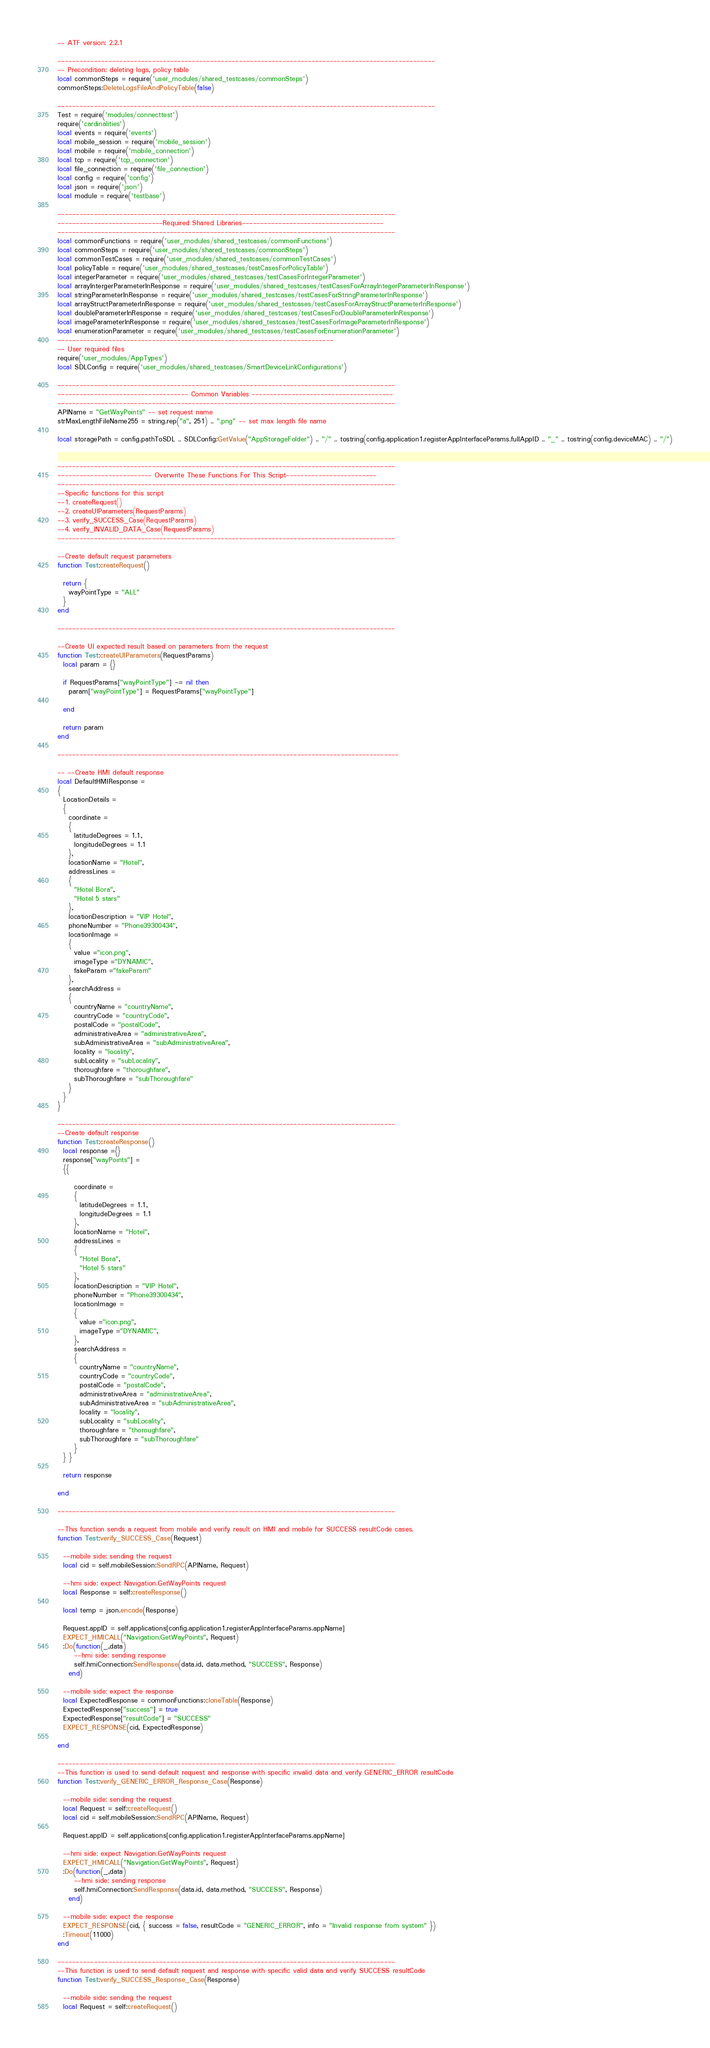<code> <loc_0><loc_0><loc_500><loc_500><_Lua_>-- ATF version: 2.2.1

--------------------------------------------------------------------------------------------------------
-- Precondition: deleting logs, policy table
local commonSteps = require('user_modules/shared_testcases/commonSteps')
commonSteps:DeleteLogsFileAndPolicyTable(false)

--------------------------------------------------------------------------------------------------------
Test = require('modules/connecttest')
require('cardinalities')
local events = require('events')
local mobile_session = require('mobile_session')
local mobile = require('mobile_connection')
local tcp = require('tcp_connection')
local file_connection = require('file_connection')
local config = require('config')
local json = require('json')
local module = require('testbase')

---------------------------------------------------------------------------------------------
-----------------------------Required Shared Libraries---------------------------------------
---------------------------------------------------------------------------------------------
local commonFunctions = require('user_modules/shared_testcases/commonFunctions')
local commonSteps = require('user_modules/shared_testcases/commonSteps')
local commonTestCases = require('user_modules/shared_testcases/commonTestCases')
local policyTable = require('user_modules/shared_testcases/testCasesForPolicyTable')
local integerParameter = require('user_modules/shared_testcases/testCasesForIntegerParameter')
local arrayIntergerParameterInResponse = require('user_modules/shared_testcases/testCasesForArrayIntegerParameterInResponse')
local stringParameterInResponse = require('user_modules/shared_testcases/testCasesForStringParameterInResponse')
local arrayStructParameterInResponse = require('user_modules/shared_testcases/testCasesForArrayStructParameterInResponse')
local doubleParameterInResponse = require('user_modules/shared_testcases/testCasesForDoubleParameterInResponse')
local imageParameterInResponse = require('user_modules/shared_testcases/testCasesForImageParameterInResponse')
local enumerationParameter = require('user_modules/shared_testcases/testCasesForEnumerationParameter')
----------------------------------------------------------------------------
-- User required files
require('user_modules/AppTypes')
local SDLConfig = require('user_modules/shared_testcases/SmartDeviceLinkConfigurations')

---------------------------------------------------------------------------------------------
------------------------------------ Common Variables ---------------------------------------
---------------------------------------------------------------------------------------------
APIName = "GetWayPoints" -- set request name
strMaxLengthFileName255 = string.rep("a", 251) .. ".png" -- set max length file name

local storagePath = config.pathToSDL .. SDLConfig:GetValue("AppStorageFolder") .. "/" .. tostring(config.application1.registerAppInterfaceParams.fullAppID .. "_" .. tostring(config.deviceMAC) .. "/")


---------------------------------------------------------------------------------------------
-------------------------- Overwrite These Functions For This Script-------------------------
---------------------------------------------------------------------------------------------
--Specific functions for this script
--1. createRequest()
--2. createUIParameters(RequestParams)
--3. verify_SUCCESS_Case(RequestParams)
--4. verify_INVALID_DATA_Case(RequestParams)
---------------------------------------------------------------------------------------------

--Create default request parameters
function Test:createRequest()

  return {
    wayPointType = "ALL"
  }
end

---------------------------------------------------------------------------------------------

--Create UI expected result based on parameters from the request
function Test:createUIParameters(RequestParams)
  local param = {}

  if RequestParams["wayPointType"] ~= nil then
    param["wayPointType"] = RequestParams["wayPointType"]

  end

  return param
end

----------------------------------------------------------------------------------------------

-- --Create HMI default response
local DefaultHMIResponse =
{
  LocationDetails =
  {
    coordinate =
    {
      latitudeDegrees = 1.1,
      longitudeDegrees = 1.1
    },
    locationName = "Hotel",
    addressLines =
    {
      "Hotel Bora",
      "Hotel 5 stars"
    },
    locationDescription = "VIP Hotel",
    phoneNumber = "Phone39300434",
    locationImage =
    {
      value ="icon.png",
      imageType ="DYNAMIC",
      fakeParam ="fakeParam"
    },
    searchAddress =
    {
      countryName = "countryName",
      countryCode = "countryCode",
      postalCode = "postalCode",
      administrativeArea = "administrativeArea",
      subAdministrativeArea = "subAdministrativeArea",
      locality = "locality",
      subLocality = "subLocality",
      thoroughfare = "thoroughfare",
      subThoroughfare = "subThoroughfare"
    }
  }
}

---------------------------------------------------------------------------------------------
--Create default response
function Test:createResponse()
  local response ={}
  response["wayPoints"] =
  {{

      coordinate =
      {
        latitudeDegrees = 1.1,
        longitudeDegrees = 1.1
      },
      locationName = "Hotel",
      addressLines =
      {
        "Hotel Bora",
        "Hotel 5 stars"
      },
      locationDescription = "VIP Hotel",
      phoneNumber = "Phone39300434",
      locationImage =
      {
        value ="icon.png",
        imageType ="DYNAMIC",
      },
      searchAddress =
      {
        countryName = "countryName",
        countryCode = "countryCode",
        postalCode = "postalCode",
        administrativeArea = "administrativeArea",
        subAdministrativeArea = "subAdministrativeArea",
        locality = "locality",
        subLocality = "subLocality",
        thoroughfare = "thoroughfare",
        subThoroughfare = "subThoroughfare"
      }
  } }

  return response

end

---------------------------------------------------------------------------------------------

--This function sends a request from mobile and verify result on HMI and mobile for SUCCESS resultCode cases.
function Test:verify_SUCCESS_Case(Request)

  --mobile side: sending the request
  local cid = self.mobileSession:SendRPC(APIName, Request)

  --hmi side: expect Navigation.GetWayPoints request
  local Response = self:createResponse()

  local temp = json.encode(Response)

  Request.appID = self.applications[config.application1.registerAppInterfaceParams.appName]
  EXPECT_HMICALL("Navigation.GetWayPoints", Request)
  :Do(function(_,data)
      --hmi side: sending response
      self.hmiConnection:SendResponse(data.id, data.method, "SUCCESS", Response)
    end)

  --mobile side: expect the response
  local ExpectedResponse = commonFunctions:cloneTable(Response)
  ExpectedResponse["success"] = true
  ExpectedResponse["resultCode"] = "SUCCESS"
  EXPECT_RESPONSE(cid, ExpectedResponse)

end

---------------------------------------------------------------------------------------------
--This function is used to send default request and response with specific invalid data and verify GENERIC_ERROR resultCode
function Test:verify_GENERIC_ERROR_Response_Case(Response)

  --mobile side: sending the request
  local Request = self:createRequest()
  local cid = self.mobileSession:SendRPC(APIName, Request)

  Request.appID = self.applications[config.application1.registerAppInterfaceParams.appName]

  --hmi side: expect Navigation.GetWayPoints request
  EXPECT_HMICALL("Navigation.GetWayPoints", Request)
  :Do(function(_,data)
      --hmi side: sending response
      self.hmiConnection:SendResponse(data.id, data.method, "SUCCESS", Response)
    end)

  --mobile side: expect the response
  EXPECT_RESPONSE(cid, { success = false, resultCode = "GENERIC_ERROR", info = "Invalid response from system" })
  :Timeout(11000)
end

---------------------------------------------------------------------------------------------
--This function is used to send default request and response with specific valid data and verify SUCCESS resultCode
function Test:verify_SUCCESS_Response_Case(Response)

  --mobile side: sending the request
  local Request = self:createRequest()</code> 